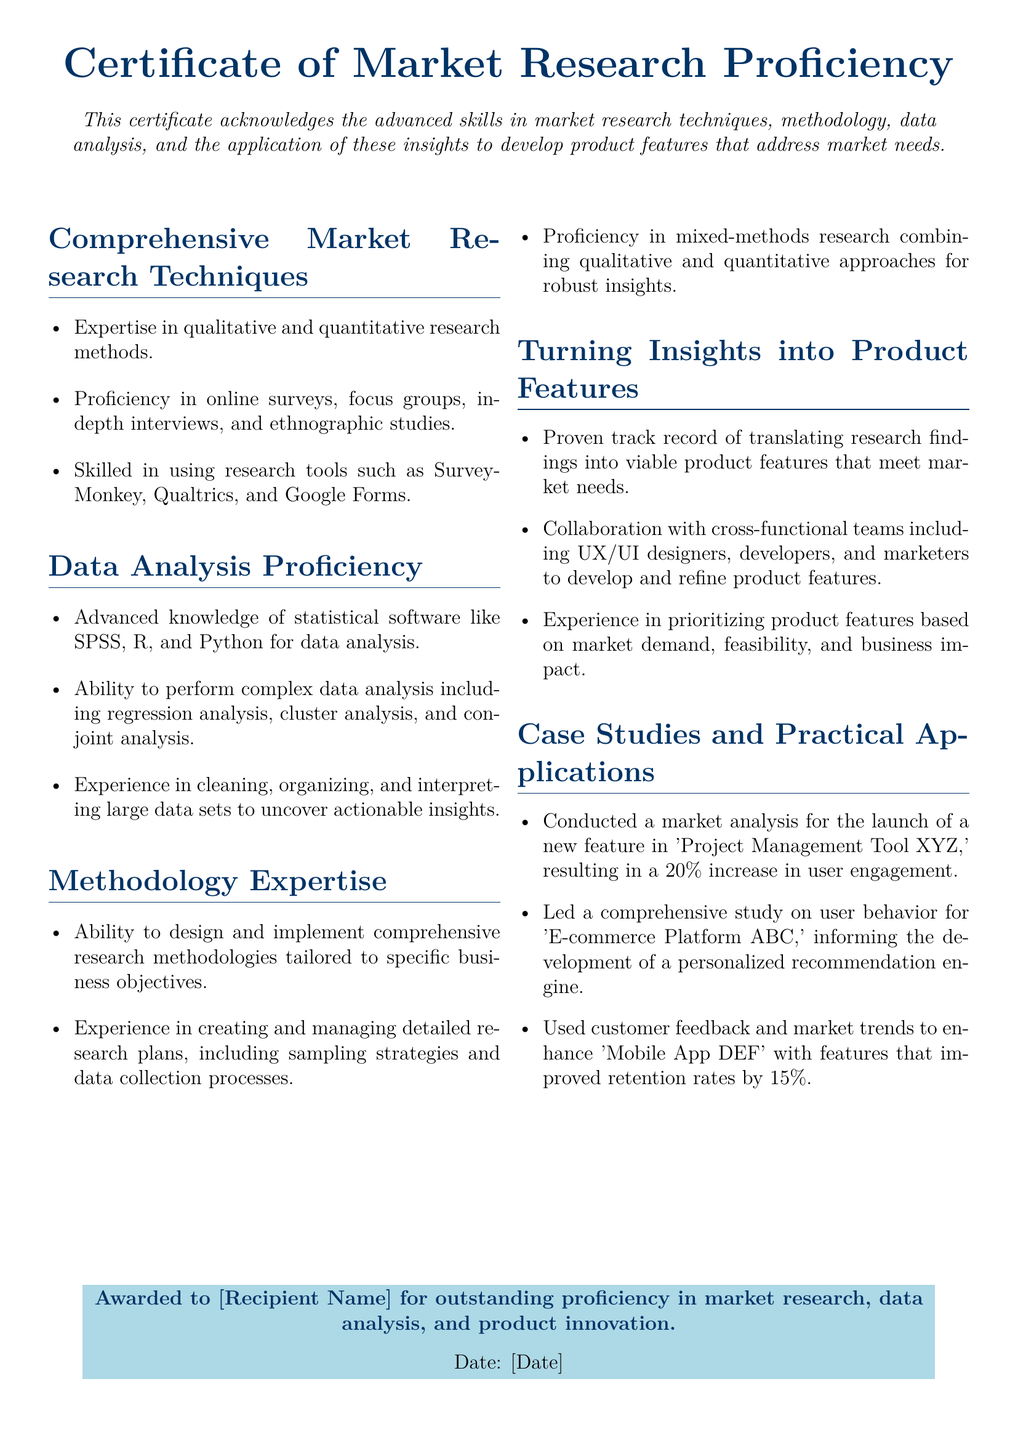What is the title of the certificate? The title of the certificate is prominently displayed at the top of the document.
Answer: Certificate of Market Research Proficiency What is acknowledged by this certificate? The document specifies what skills are acknowledged under this certificate in the introductory text.
Answer: Advanced skills in market research techniques Which methodology is highlighted in the certificate? The methodologies section details the aspects of market research highlighted in the document.
Answer: Comprehensive research methodologies What is one tool mentioned for data analysis proficiency? The document lists specific tools that are relevant to data analysis.
Answer: SPSS What percentage increase in user engagement was achieved by the market analysis? The document provides specific results from one of the case studies.
Answer: 20% Who is awarded the certificate? The certificate section indicates who the award is designated for.
Answer: [Recipient Name] What is the color of the box containing the award statement? The document describes the color of the box where the award text is shown.
Answer: Light blue What significant behavior study was conducted for 'E-commerce Platform ABC'? The document summarizes a specific study that influenced product development.
Answer: User behavior study When was the certificate awarded? The document includes a placeholder for the date on which the certificate is given.
Answer: [Date] 